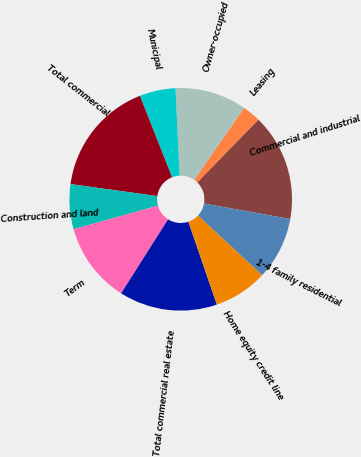Convert chart. <chart><loc_0><loc_0><loc_500><loc_500><pie_chart><fcel>Commercial and industrial<fcel>Leasing<fcel>Owner-occupied<fcel>Municipal<fcel>Total commercial<fcel>Construction and land<fcel>Term<fcel>Total commercial real estate<fcel>Home equity credit line<fcel>1-4 family residential<nl><fcel>15.55%<fcel>2.65%<fcel>10.39%<fcel>5.23%<fcel>16.84%<fcel>6.52%<fcel>11.68%<fcel>14.26%<fcel>7.81%<fcel>9.1%<nl></chart> 